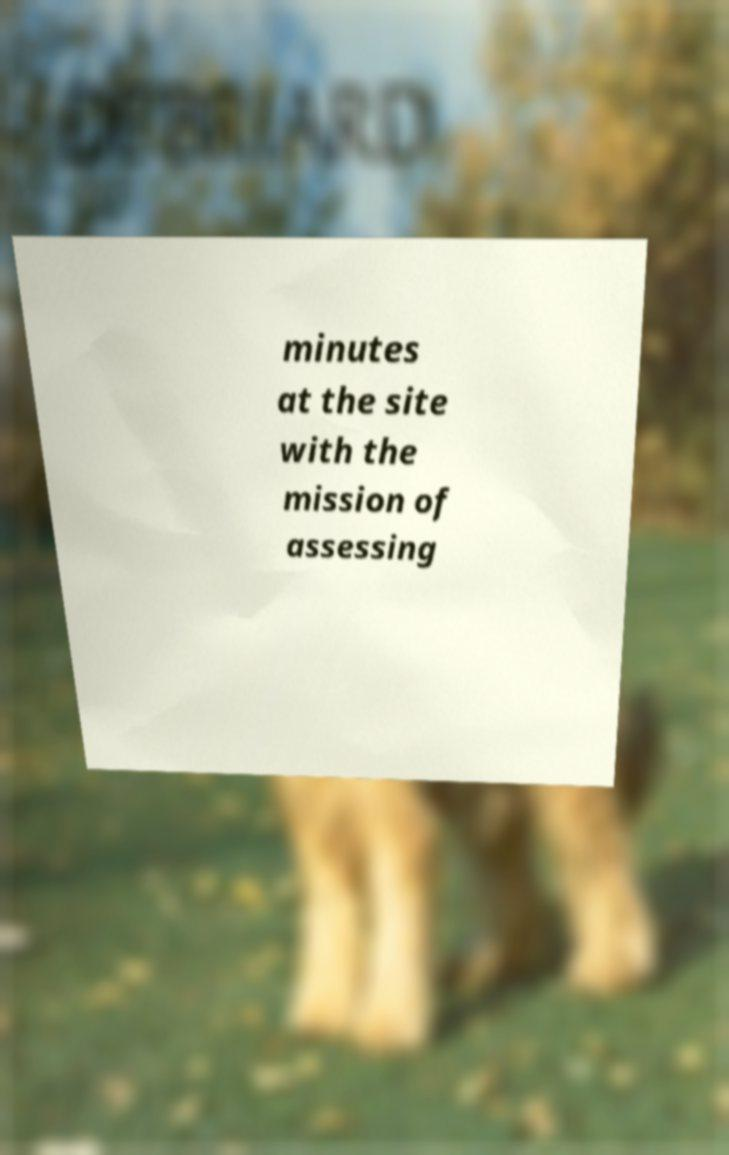There's text embedded in this image that I need extracted. Can you transcribe it verbatim? minutes at the site with the mission of assessing 